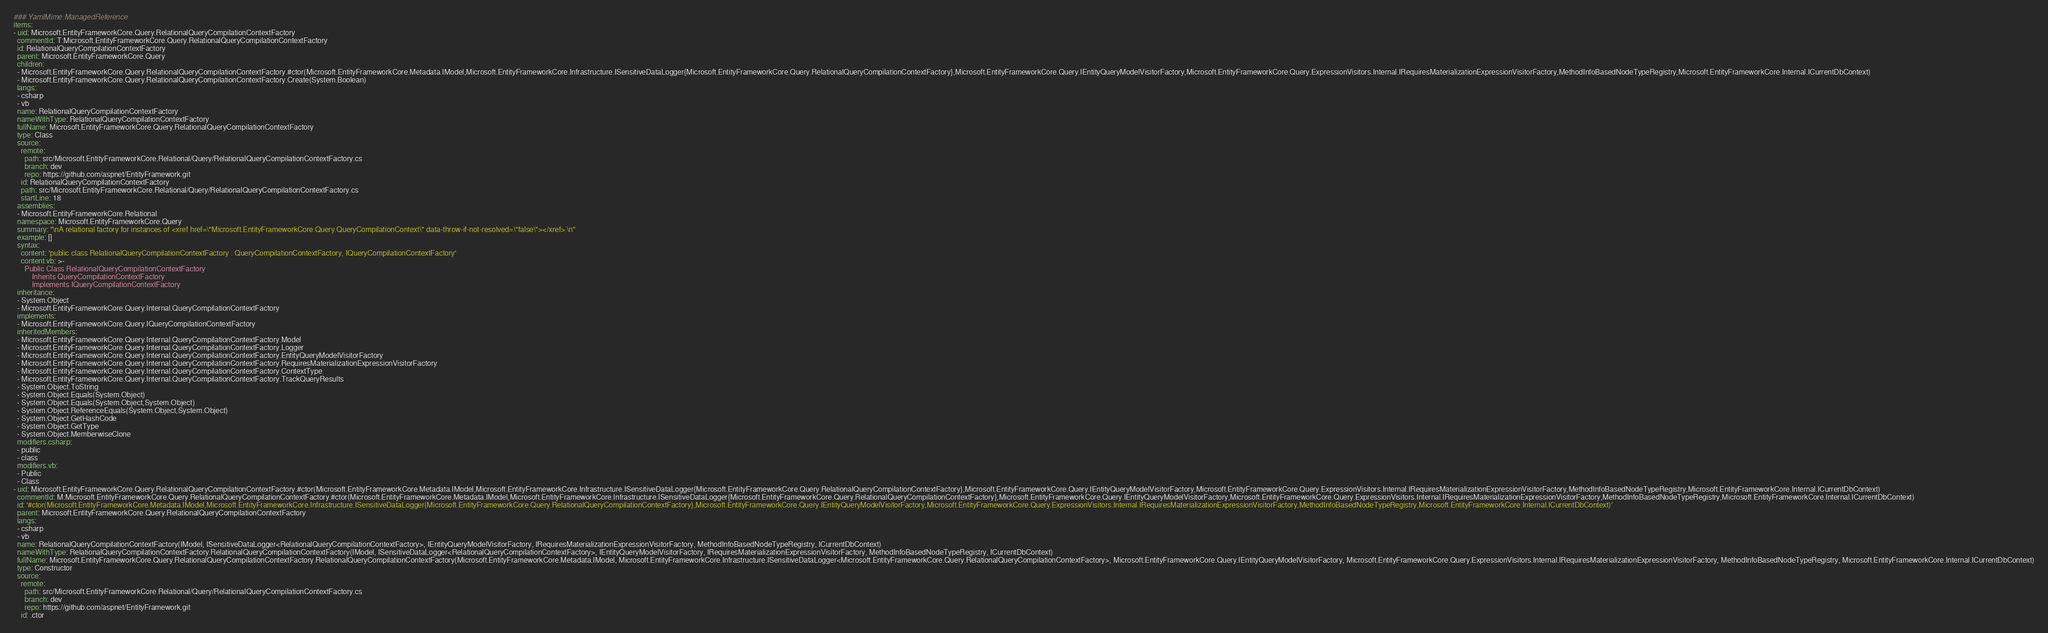<code> <loc_0><loc_0><loc_500><loc_500><_YAML_>### YamlMime:ManagedReference
items:
- uid: Microsoft.EntityFrameworkCore.Query.RelationalQueryCompilationContextFactory
  commentId: T:Microsoft.EntityFrameworkCore.Query.RelationalQueryCompilationContextFactory
  id: RelationalQueryCompilationContextFactory
  parent: Microsoft.EntityFrameworkCore.Query
  children:
  - Microsoft.EntityFrameworkCore.Query.RelationalQueryCompilationContextFactory.#ctor(Microsoft.EntityFrameworkCore.Metadata.IModel,Microsoft.EntityFrameworkCore.Infrastructure.ISensitiveDataLogger{Microsoft.EntityFrameworkCore.Query.RelationalQueryCompilationContextFactory},Microsoft.EntityFrameworkCore.Query.IEntityQueryModelVisitorFactory,Microsoft.EntityFrameworkCore.Query.ExpressionVisitors.Internal.IRequiresMaterializationExpressionVisitorFactory,MethodInfoBasedNodeTypeRegistry,Microsoft.EntityFrameworkCore.Internal.ICurrentDbContext)
  - Microsoft.EntityFrameworkCore.Query.RelationalQueryCompilationContextFactory.Create(System.Boolean)
  langs:
  - csharp
  - vb
  name: RelationalQueryCompilationContextFactory
  nameWithType: RelationalQueryCompilationContextFactory
  fullName: Microsoft.EntityFrameworkCore.Query.RelationalQueryCompilationContextFactory
  type: Class
  source:
    remote:
      path: src/Microsoft.EntityFrameworkCore.Relational/Query/RelationalQueryCompilationContextFactory.cs
      branch: dev
      repo: https://github.com/aspnet/EntityFramework.git
    id: RelationalQueryCompilationContextFactory
    path: src/Microsoft.EntityFrameworkCore.Relational/Query/RelationalQueryCompilationContextFactory.cs
    startLine: 18
  assemblies:
  - Microsoft.EntityFrameworkCore.Relational
  namespace: Microsoft.EntityFrameworkCore.Query
  summary: "\nA relational factory for instances of <xref href=\"Microsoft.EntityFrameworkCore.Query.QueryCompilationContext\" data-throw-if-not-resolved=\"false\"></xref>.\n"
  example: []
  syntax:
    content: 'public class RelationalQueryCompilationContextFactory : QueryCompilationContextFactory, IQueryCompilationContextFactory'
    content.vb: >-
      Public Class RelationalQueryCompilationContextFactory
          Inherits QueryCompilationContextFactory
          Implements IQueryCompilationContextFactory
  inheritance:
  - System.Object
  - Microsoft.EntityFrameworkCore.Query.Internal.QueryCompilationContextFactory
  implements:
  - Microsoft.EntityFrameworkCore.Query.IQueryCompilationContextFactory
  inheritedMembers:
  - Microsoft.EntityFrameworkCore.Query.Internal.QueryCompilationContextFactory.Model
  - Microsoft.EntityFrameworkCore.Query.Internal.QueryCompilationContextFactory.Logger
  - Microsoft.EntityFrameworkCore.Query.Internal.QueryCompilationContextFactory.EntityQueryModelVisitorFactory
  - Microsoft.EntityFrameworkCore.Query.Internal.QueryCompilationContextFactory.RequiresMaterializationExpressionVisitorFactory
  - Microsoft.EntityFrameworkCore.Query.Internal.QueryCompilationContextFactory.ContextType
  - Microsoft.EntityFrameworkCore.Query.Internal.QueryCompilationContextFactory.TrackQueryResults
  - System.Object.ToString
  - System.Object.Equals(System.Object)
  - System.Object.Equals(System.Object,System.Object)
  - System.Object.ReferenceEquals(System.Object,System.Object)
  - System.Object.GetHashCode
  - System.Object.GetType
  - System.Object.MemberwiseClone
  modifiers.csharp:
  - public
  - class
  modifiers.vb:
  - Public
  - Class
- uid: Microsoft.EntityFrameworkCore.Query.RelationalQueryCompilationContextFactory.#ctor(Microsoft.EntityFrameworkCore.Metadata.IModel,Microsoft.EntityFrameworkCore.Infrastructure.ISensitiveDataLogger{Microsoft.EntityFrameworkCore.Query.RelationalQueryCompilationContextFactory},Microsoft.EntityFrameworkCore.Query.IEntityQueryModelVisitorFactory,Microsoft.EntityFrameworkCore.Query.ExpressionVisitors.Internal.IRequiresMaterializationExpressionVisitorFactory,MethodInfoBasedNodeTypeRegistry,Microsoft.EntityFrameworkCore.Internal.ICurrentDbContext)
  commentId: M:Microsoft.EntityFrameworkCore.Query.RelationalQueryCompilationContextFactory.#ctor(Microsoft.EntityFrameworkCore.Metadata.IModel,Microsoft.EntityFrameworkCore.Infrastructure.ISensitiveDataLogger{Microsoft.EntityFrameworkCore.Query.RelationalQueryCompilationContextFactory},Microsoft.EntityFrameworkCore.Query.IEntityQueryModelVisitorFactory,Microsoft.EntityFrameworkCore.Query.ExpressionVisitors.Internal.IRequiresMaterializationExpressionVisitorFactory,MethodInfoBasedNodeTypeRegistry,Microsoft.EntityFrameworkCore.Internal.ICurrentDbContext)
  id: '#ctor(Microsoft.EntityFrameworkCore.Metadata.IModel,Microsoft.EntityFrameworkCore.Infrastructure.ISensitiveDataLogger{Microsoft.EntityFrameworkCore.Query.RelationalQueryCompilationContextFactory},Microsoft.EntityFrameworkCore.Query.IEntityQueryModelVisitorFactory,Microsoft.EntityFrameworkCore.Query.ExpressionVisitors.Internal.IRequiresMaterializationExpressionVisitorFactory,MethodInfoBasedNodeTypeRegistry,Microsoft.EntityFrameworkCore.Internal.ICurrentDbContext)'
  parent: Microsoft.EntityFrameworkCore.Query.RelationalQueryCompilationContextFactory
  langs:
  - csharp
  - vb
  name: RelationalQueryCompilationContextFactory(IModel, ISensitiveDataLogger<RelationalQueryCompilationContextFactory>, IEntityQueryModelVisitorFactory, IRequiresMaterializationExpressionVisitorFactory, MethodInfoBasedNodeTypeRegistry, ICurrentDbContext)
  nameWithType: RelationalQueryCompilationContextFactory.RelationalQueryCompilationContextFactory(IModel, ISensitiveDataLogger<RelationalQueryCompilationContextFactory>, IEntityQueryModelVisitorFactory, IRequiresMaterializationExpressionVisitorFactory, MethodInfoBasedNodeTypeRegistry, ICurrentDbContext)
  fullName: Microsoft.EntityFrameworkCore.Query.RelationalQueryCompilationContextFactory.RelationalQueryCompilationContextFactory(Microsoft.EntityFrameworkCore.Metadata.IModel, Microsoft.EntityFrameworkCore.Infrastructure.ISensitiveDataLogger<Microsoft.EntityFrameworkCore.Query.RelationalQueryCompilationContextFactory>, Microsoft.EntityFrameworkCore.Query.IEntityQueryModelVisitorFactory, Microsoft.EntityFrameworkCore.Query.ExpressionVisitors.Internal.IRequiresMaterializationExpressionVisitorFactory, MethodInfoBasedNodeTypeRegistry, Microsoft.EntityFrameworkCore.Internal.ICurrentDbContext)
  type: Constructor
  source:
    remote:
      path: src/Microsoft.EntityFrameworkCore.Relational/Query/RelationalQueryCompilationContextFactory.cs
      branch: dev
      repo: https://github.com/aspnet/EntityFramework.git
    id: .ctor</code> 